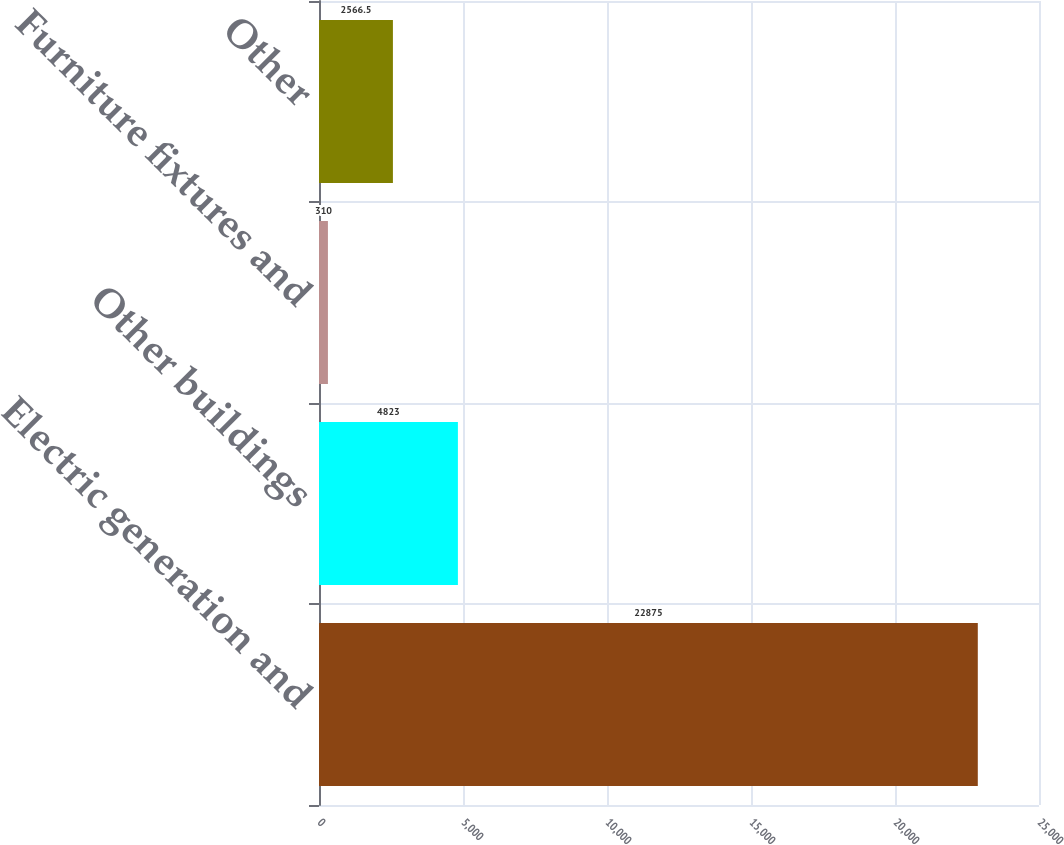Convert chart. <chart><loc_0><loc_0><loc_500><loc_500><bar_chart><fcel>Electric generation and<fcel>Other buildings<fcel>Furniture fixtures and<fcel>Other<nl><fcel>22875<fcel>4823<fcel>310<fcel>2566.5<nl></chart> 